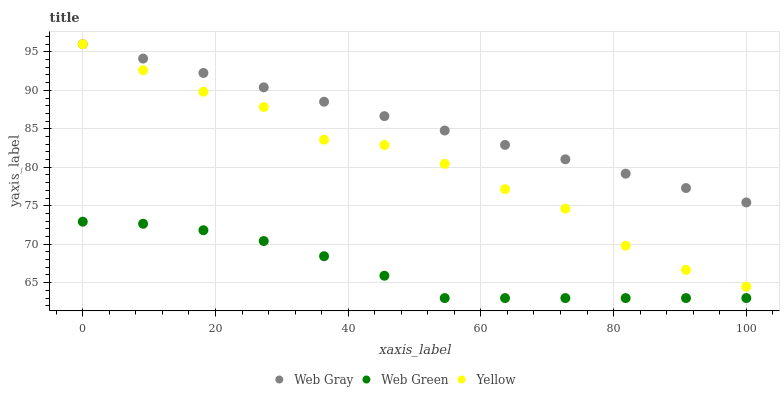Does Web Green have the minimum area under the curve?
Answer yes or no. Yes. Does Web Gray have the maximum area under the curve?
Answer yes or no. Yes. Does Yellow have the minimum area under the curve?
Answer yes or no. No. Does Yellow have the maximum area under the curve?
Answer yes or no. No. Is Web Gray the smoothest?
Answer yes or no. Yes. Is Yellow the roughest?
Answer yes or no. Yes. Is Web Green the smoothest?
Answer yes or no. No. Is Web Green the roughest?
Answer yes or no. No. Does Web Green have the lowest value?
Answer yes or no. Yes. Does Yellow have the lowest value?
Answer yes or no. No. Does Yellow have the highest value?
Answer yes or no. Yes. Does Web Green have the highest value?
Answer yes or no. No. Is Web Green less than Web Gray?
Answer yes or no. Yes. Is Yellow greater than Web Green?
Answer yes or no. Yes. Does Web Gray intersect Yellow?
Answer yes or no. Yes. Is Web Gray less than Yellow?
Answer yes or no. No. Is Web Gray greater than Yellow?
Answer yes or no. No. Does Web Green intersect Web Gray?
Answer yes or no. No. 